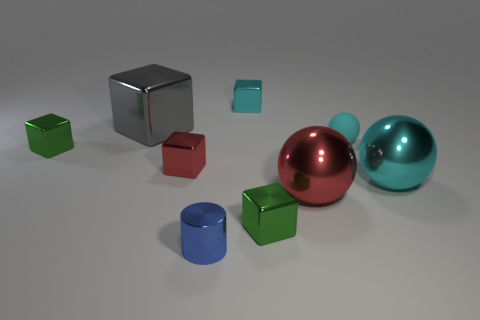Are there any other things that are the same shape as the gray shiny object?
Your response must be concise. Yes. What color is the big object that is the same shape as the tiny red metallic thing?
Keep it short and to the point. Gray. What is the material of the green block that is right of the small blue metal cylinder?
Your answer should be very brief. Metal. The tiny matte object has what color?
Give a very brief answer. Cyan. Do the green metallic cube behind the red ball and the rubber object have the same size?
Your answer should be very brief. Yes. The small green block behind the green shiny object that is in front of the green cube that is to the left of the tiny metal cylinder is made of what material?
Offer a terse response. Metal. There is a shiny cube to the right of the cyan block; is its color the same as the big shiny thing that is to the left of the tiny cyan block?
Your answer should be compact. No. What material is the blue cylinder that is to the left of the ball on the right side of the tiny cyan rubber thing made of?
Your response must be concise. Metal. What color is the shiny cylinder that is the same size as the rubber object?
Keep it short and to the point. Blue. Is the shape of the small blue metallic object the same as the small rubber object to the right of the small blue object?
Make the answer very short. No. 